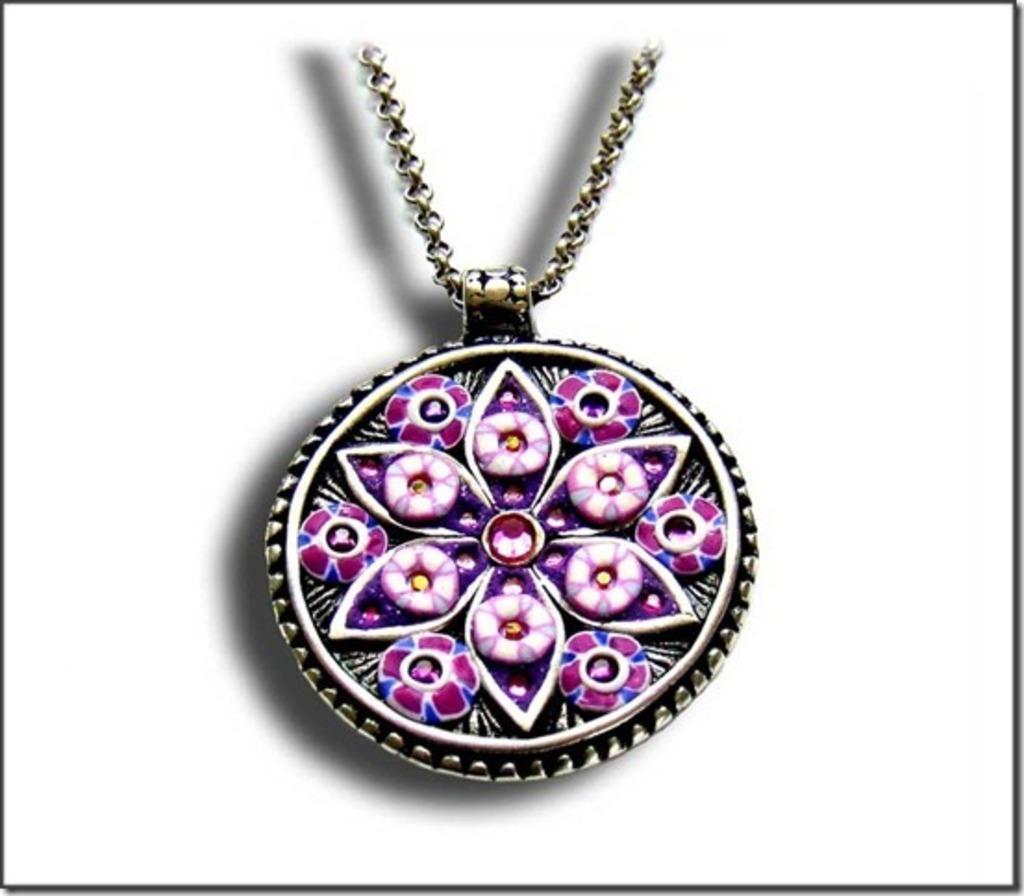Could you give a brief overview of what you see in this image? In this image I can see a locket and the locket is in blue and pink color and I can also see a chain, and I can see white color background. 